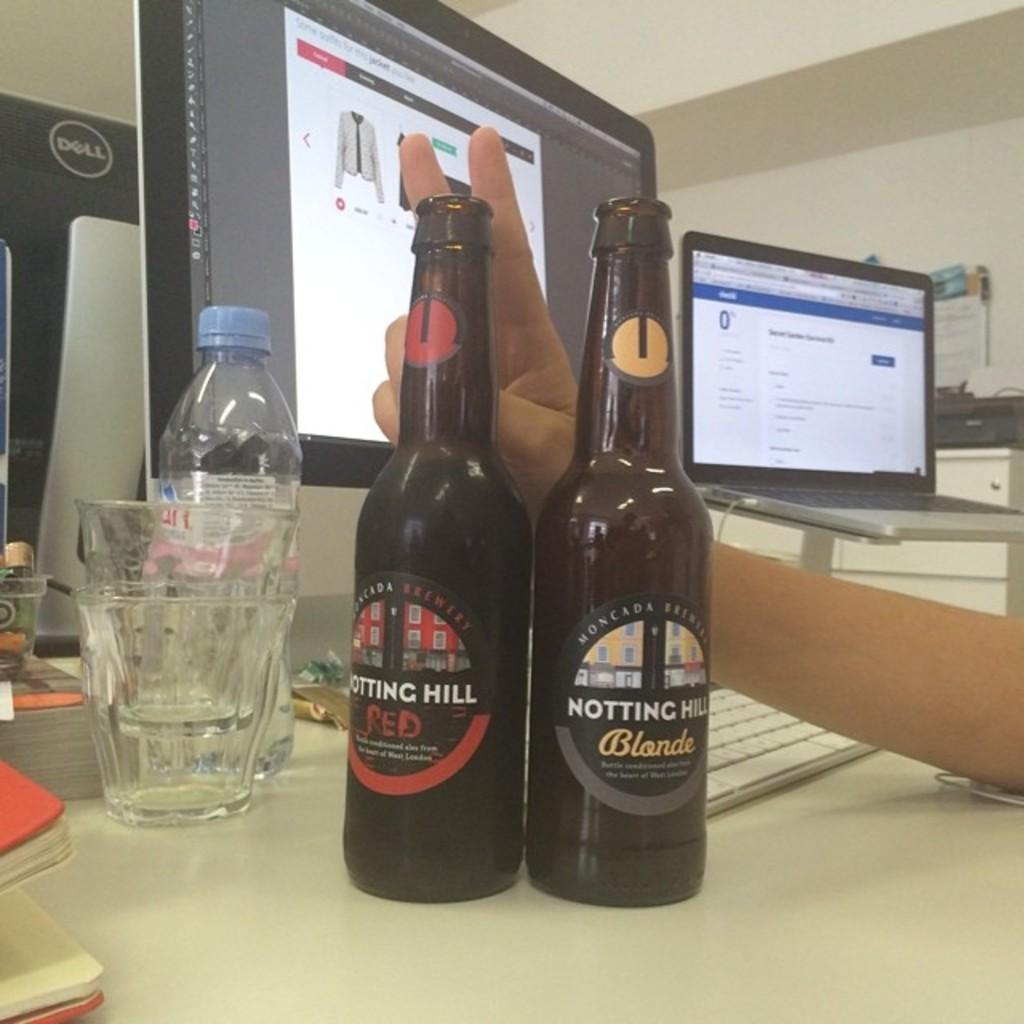<image>
Relay a brief, clear account of the picture shown. Two bottles of Notting Hill beer, one "Red" and one "Blonde" with two empty glasses stacked in each other to the side. 